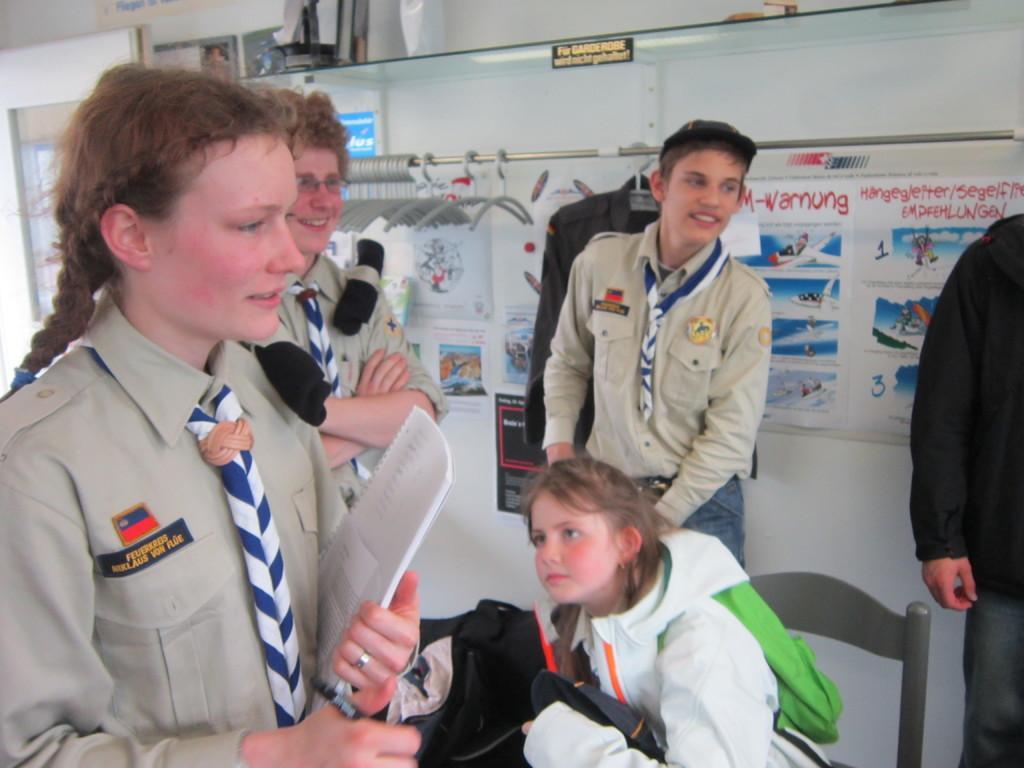Describe this image in one or two sentences. In this picture I can see a person sitting on the chair and holding an object, there are group of people standing, a person holding a book, there are posters on the wall, and in the background there are clothes hangers hanging to the iron rod and there are some objects on the glass shelf. 